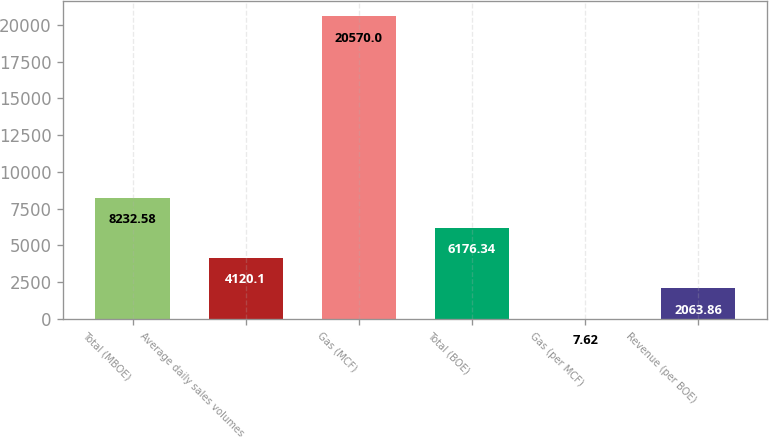Convert chart. <chart><loc_0><loc_0><loc_500><loc_500><bar_chart><fcel>Total (MBOE)<fcel>Average daily sales volumes<fcel>Gas (MCF)<fcel>Total (BOE)<fcel>Gas (per MCF)<fcel>Revenue (per BOE)<nl><fcel>8232.58<fcel>4120.1<fcel>20570<fcel>6176.34<fcel>7.62<fcel>2063.86<nl></chart> 